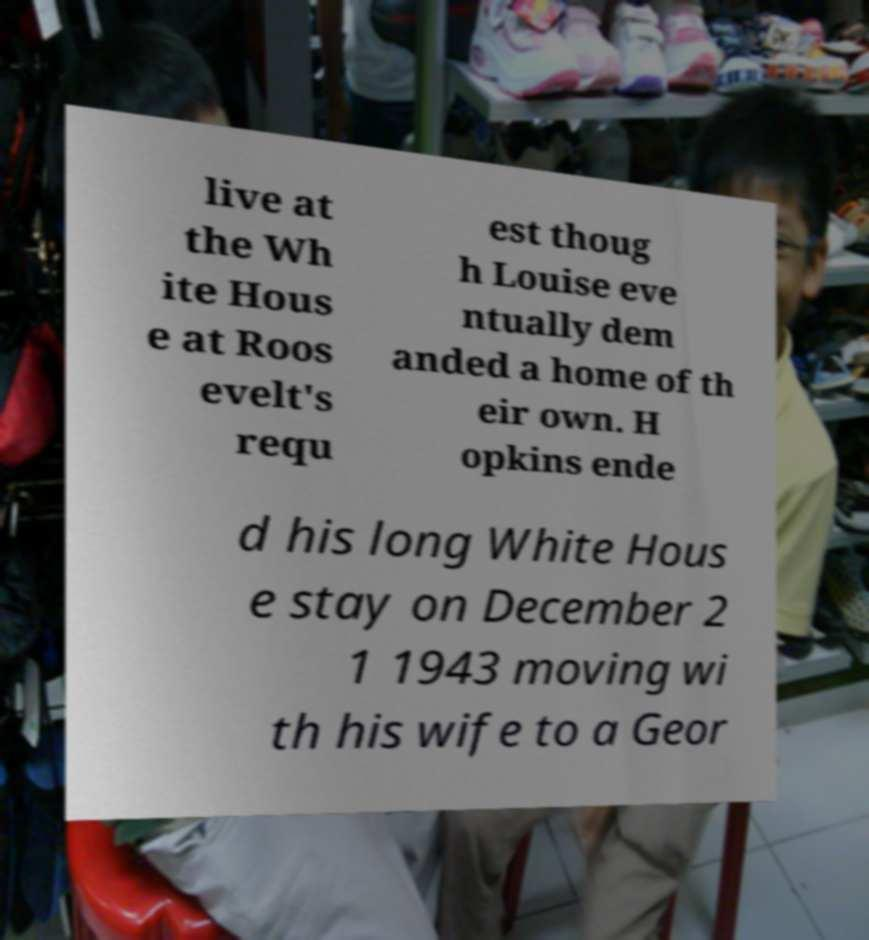Can you accurately transcribe the text from the provided image for me? live at the Wh ite Hous e at Roos evelt's requ est thoug h Louise eve ntually dem anded a home of th eir own. H opkins ende d his long White Hous e stay on December 2 1 1943 moving wi th his wife to a Geor 